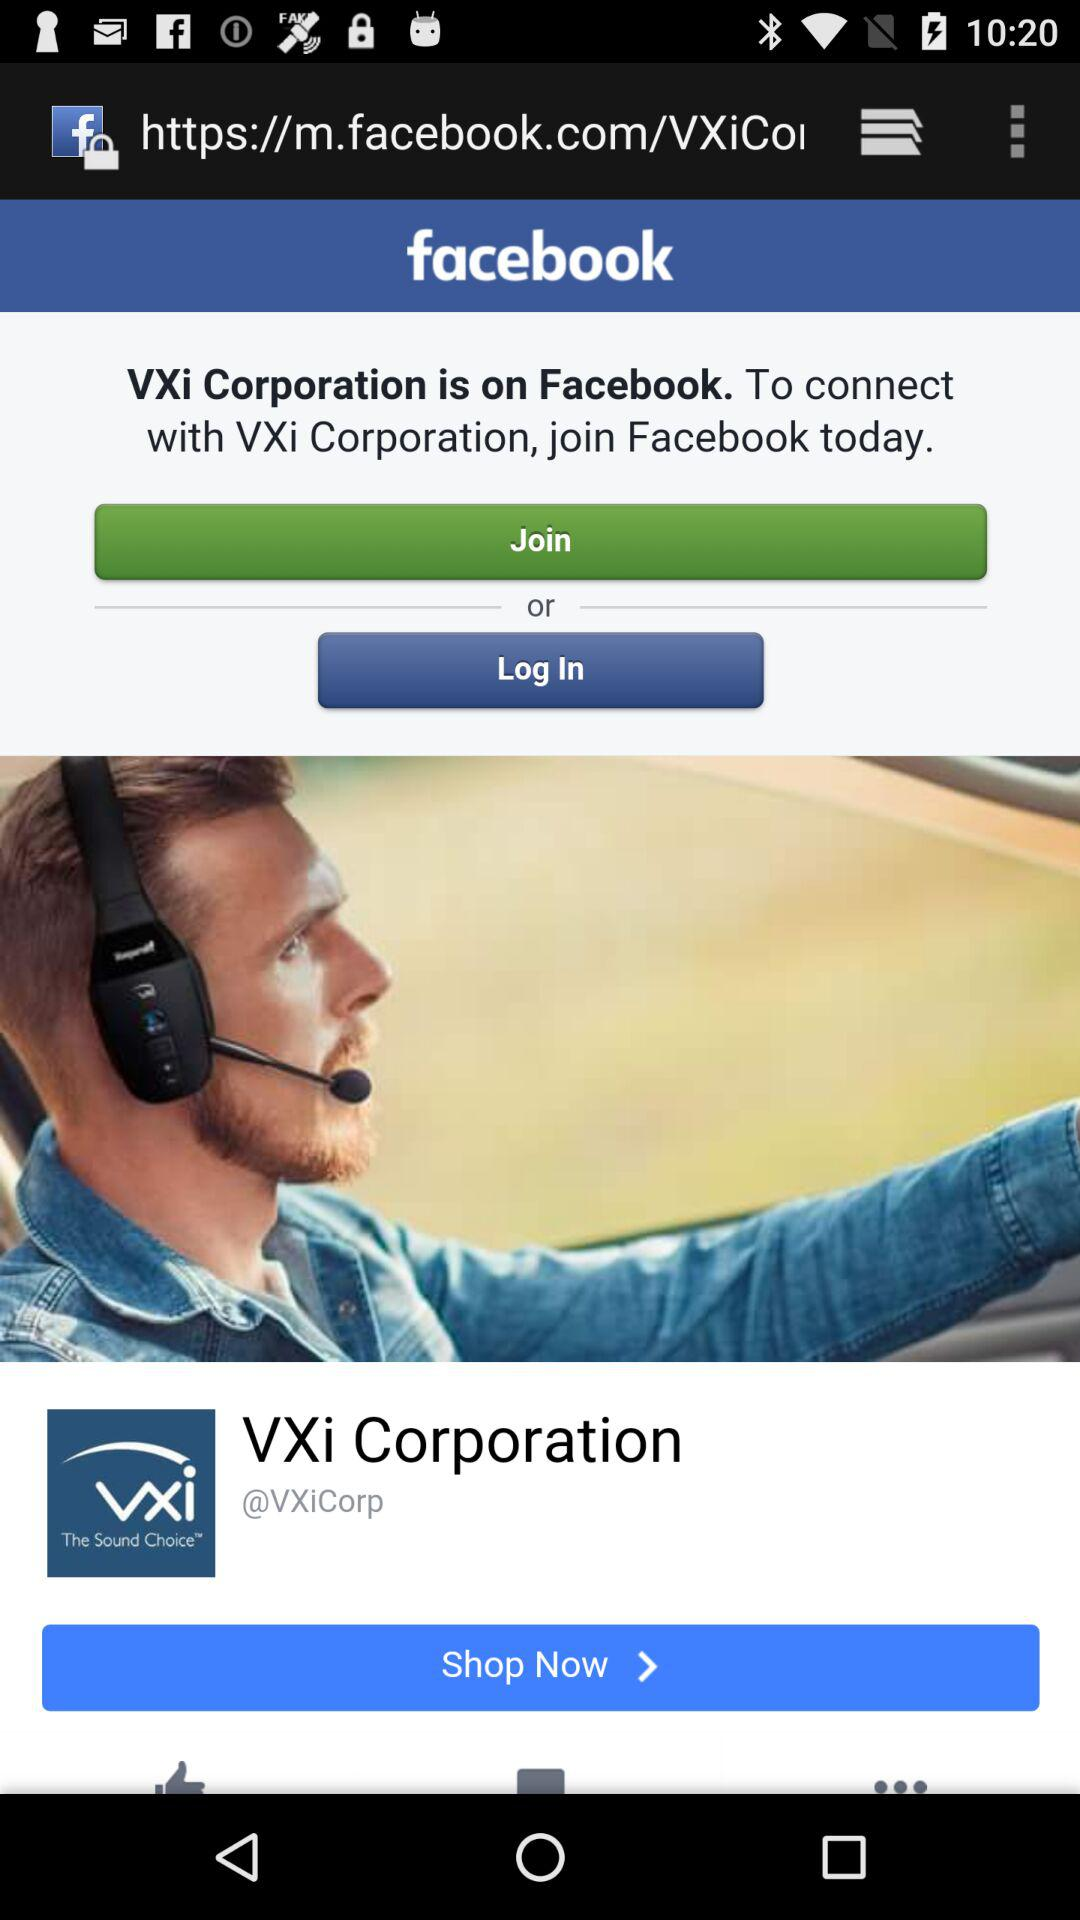What application can be used to log in? The application "facebook" can be used to log in. 